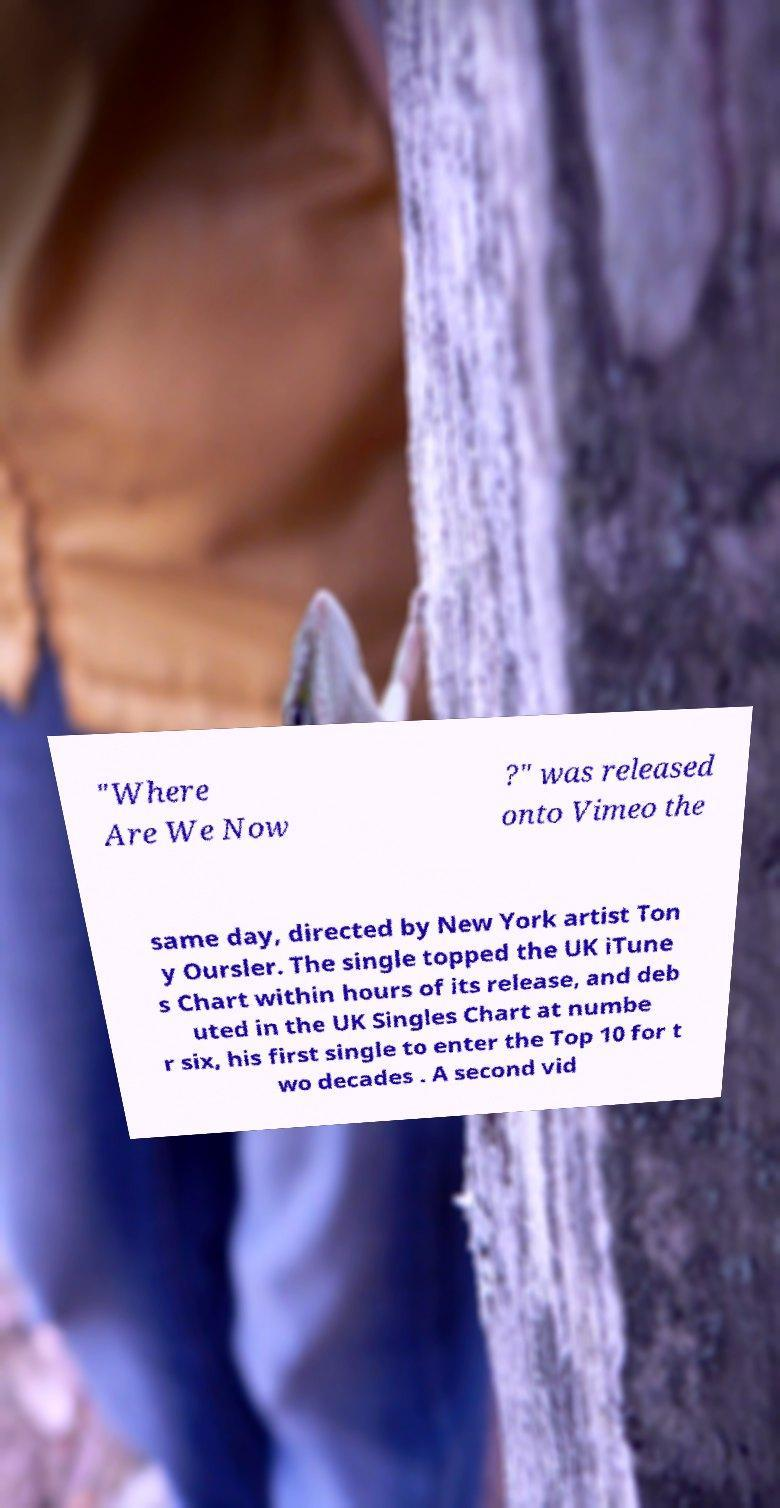Can you accurately transcribe the text from the provided image for me? "Where Are We Now ?" was released onto Vimeo the same day, directed by New York artist Ton y Oursler. The single topped the UK iTune s Chart within hours of its release, and deb uted in the UK Singles Chart at numbe r six, his first single to enter the Top 10 for t wo decades . A second vid 